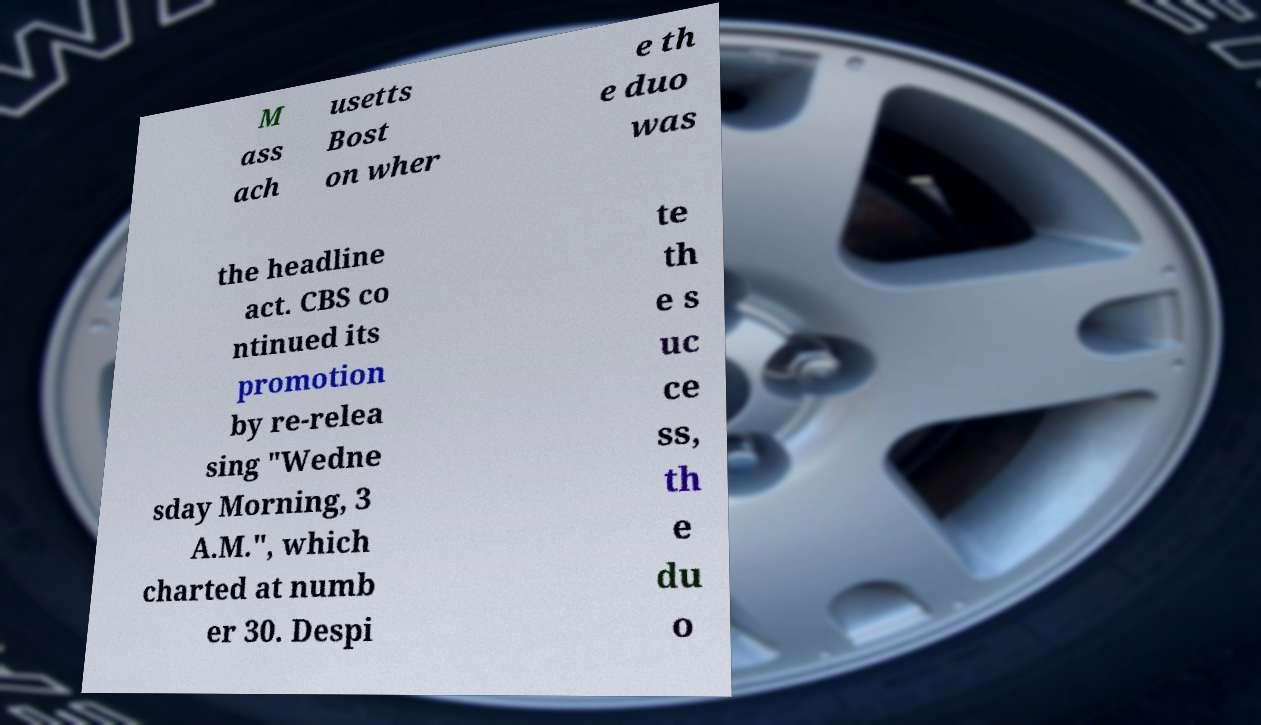I need the written content from this picture converted into text. Can you do that? M ass ach usetts Bost on wher e th e duo was the headline act. CBS co ntinued its promotion by re-relea sing "Wedne sday Morning, 3 A.M.", which charted at numb er 30. Despi te th e s uc ce ss, th e du o 